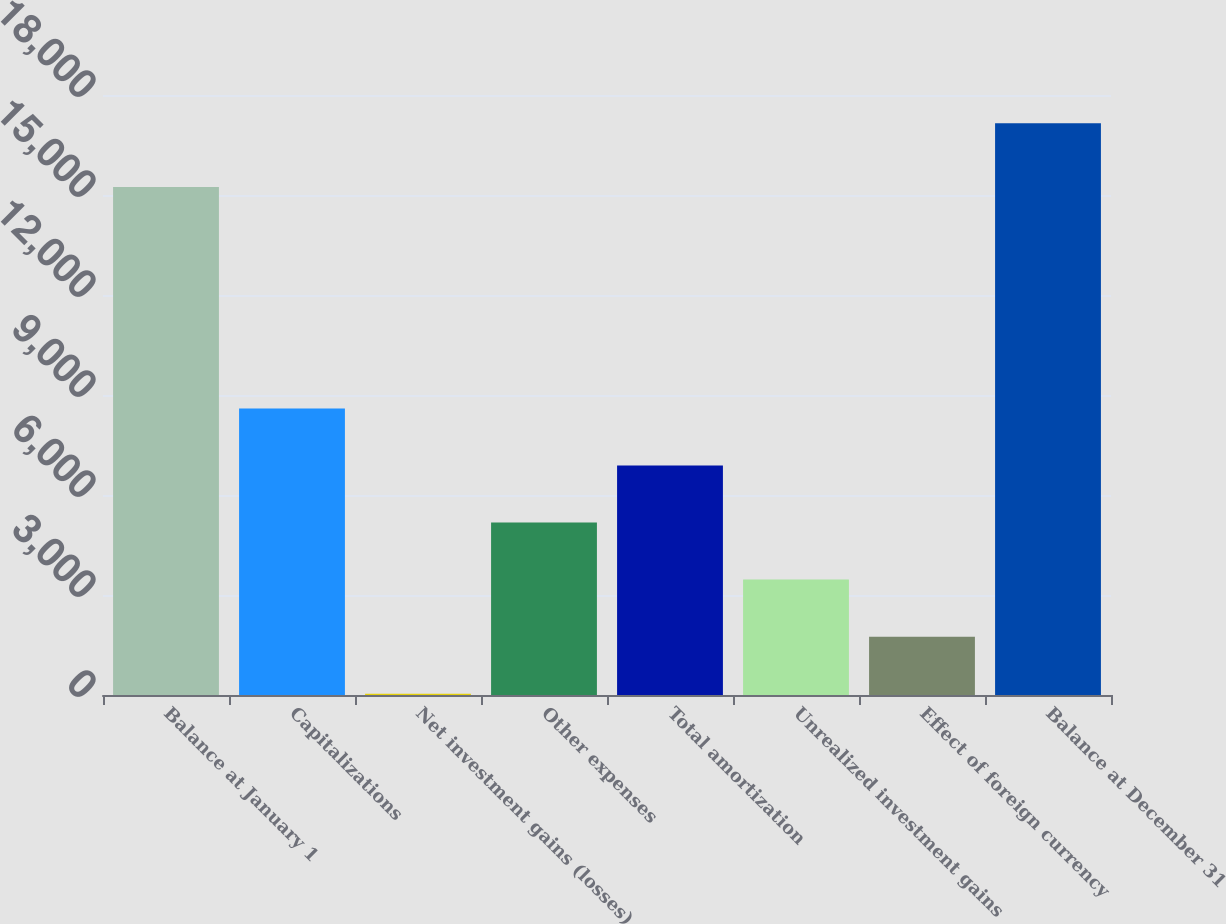Convert chart. <chart><loc_0><loc_0><loc_500><loc_500><bar_chart><fcel>Balance at January 1<fcel>Capitalizations<fcel>Net investment gains (losses)<fcel>Other expenses<fcel>Total amortization<fcel>Unrealized investment gains<fcel>Effect of foreign currency<fcel>Balance at December 31<nl><fcel>15240<fcel>8595<fcel>40<fcel>5173<fcel>6884<fcel>3462<fcel>1751<fcel>17150<nl></chart> 